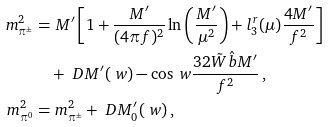Convert formula to latex. <formula><loc_0><loc_0><loc_500><loc_500>m _ { \pi ^ { \pm } } ^ { 2 } = & \ M ^ { \prime } \left [ 1 + \frac { M ^ { \prime } } { ( 4 \pi f ) ^ { 2 } } \ln \left ( \frac { M ^ { \prime } } { \mu ^ { 2 } } \right ) + l _ { 3 } ^ { r } ( \mu ) \frac { 4 M ^ { \prime } } { f ^ { 2 } } \right ] \\ & + \ D M ^ { \prime } ( \ w ) - \cos \ w \frac { 3 2 \tilde { W } \hat { b } M ^ { \prime } } { f ^ { 2 } } \, , \\ m _ { \pi ^ { 0 } } ^ { 2 } = & \ m _ { \pi ^ { \pm } } ^ { 2 } + \ D M ^ { \prime } _ { 0 } ( \ w ) \, ,</formula> 